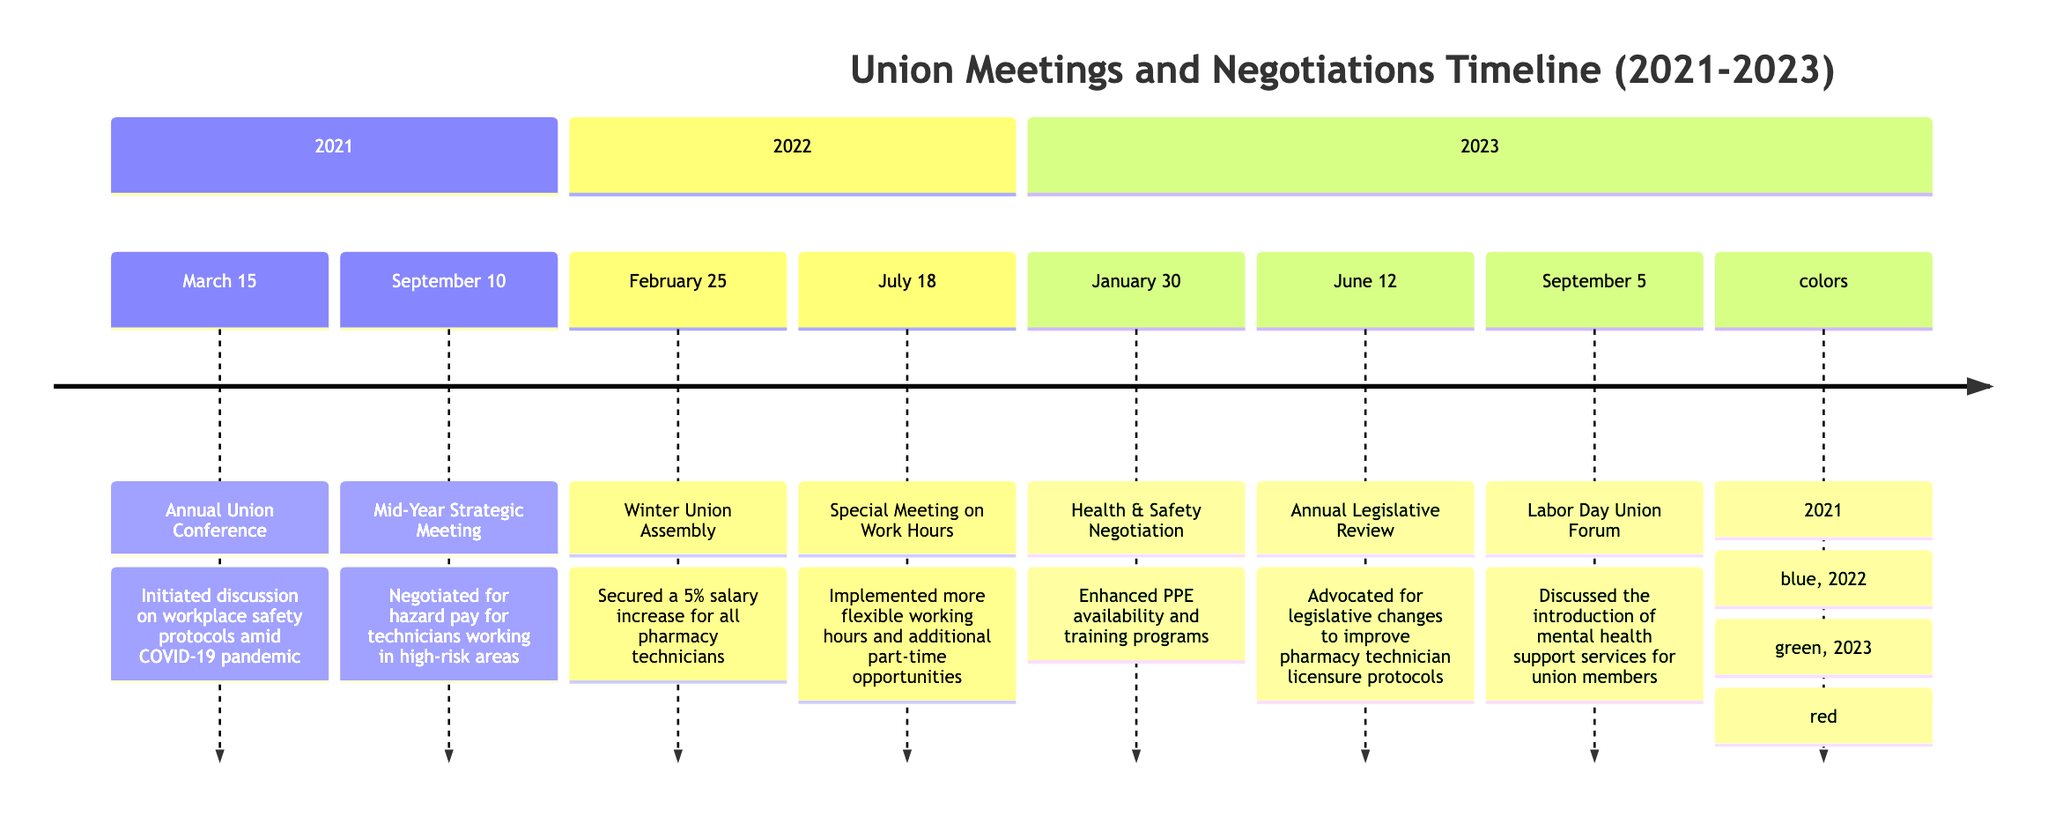What event occurred on March 15, 2021? The diagram indicates that on March 15, 2021, the event was the "Annual Union Conference."
Answer: Annual Union Conference What was the outcome of the Winter Union Assembly? According to the diagram, the outcome of the Winter Union Assembly on February 25, 2022, was securing a 5% salary increase for all pharmacy technicians.
Answer: Secured a 5% salary increase How many union events occurred in 2022? The timeline shows two events listed in 2022: the Winter Union Assembly and the Special Meeting on Work Hours, which totals to two events.
Answer: 2 Which event directly discussed mental health services? The diagram states that the "Labor Day Union Forum," held on September 5, 2023, discussed the introduction of mental health support services for union members.
Answer: Labor Day Union Forum What negotiation outcome was achieved on January 30, 2023? The outcomes listed for January 30, 2023, mention enhanced availability of Personal Protective Equipment (PPE) and training programs.
Answer: Enhanced PPE availability Which year had the most events in the timeline provided? By reviewing the timeline, we see that 2023 had three events: Health & Safety Negotiation, Annual Legislative Review, and Labor Day Union Forum, making it the year with the most events.
Answer: 2023 What was the focus of the Mid-Year Strategic Meeting? The diagram specifies that the Mid-Year Strategic Meeting on September 10, 2021, focused on negotiating for hazard pay for technicians working in high-risk areas.
Answer: Hazard pay negotiation How did the Annual Legislative Review contribute to pharmacy technicians? The diagram notes that the Annual Legislative Review on June 12, 2023, advocated for legislative changes to improve pharmacy technician licensure protocols, contributing to the professional standards of pharmacy technicians.
Answer: Legislative changes for licensure What color represents the events in 2022? The diagram indicates that events from 2022 are represented in green.
Answer: Green 